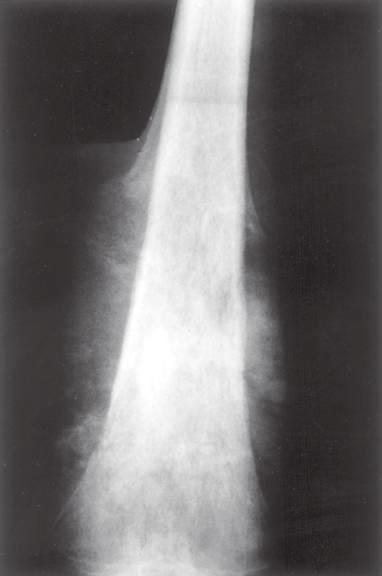has the periosteum, which has been lifted, laid down a triangular shell of reactive bone known as a codman triangle?
Answer the question using a single word or phrase. Yes 